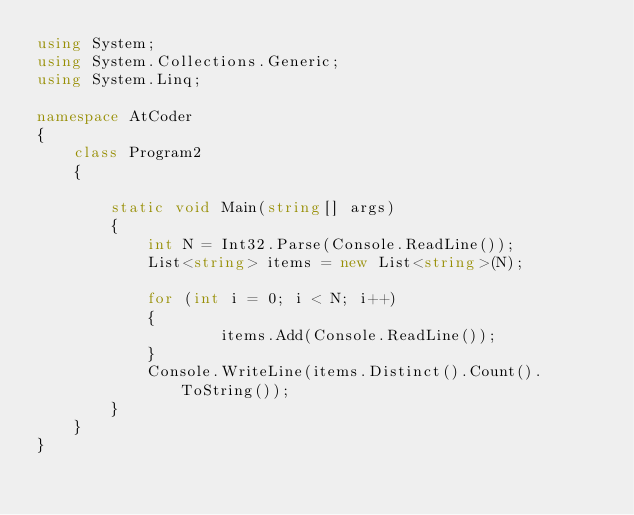<code> <loc_0><loc_0><loc_500><loc_500><_C#_>using System;
using System.Collections.Generic;
using System.Linq;

namespace AtCoder
{
    class Program2
    {

        static void Main(string[] args)
        {
            int N = Int32.Parse(Console.ReadLine());
            List<string> items = new List<string>(N);

            for (int i = 0; i < N; i++)
            {
                    items.Add(Console.ReadLine());
            }
            Console.WriteLine(items.Distinct().Count().ToString());
        }
    }
}</code> 